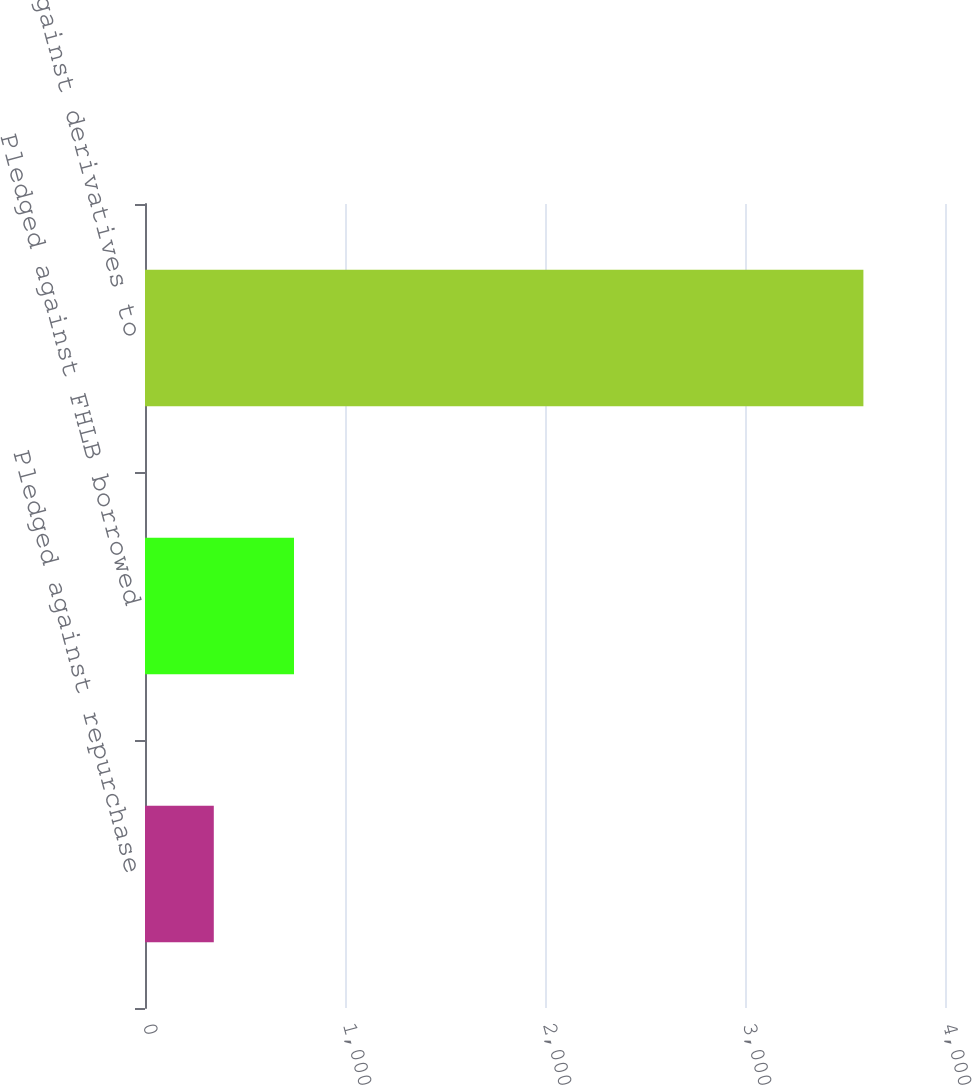Convert chart. <chart><loc_0><loc_0><loc_500><loc_500><bar_chart><fcel>Pledged against repurchase<fcel>Pledged against FHLB borrowed<fcel>Pledged against derivatives to<nl><fcel>344<fcel>745<fcel>3592<nl></chart> 